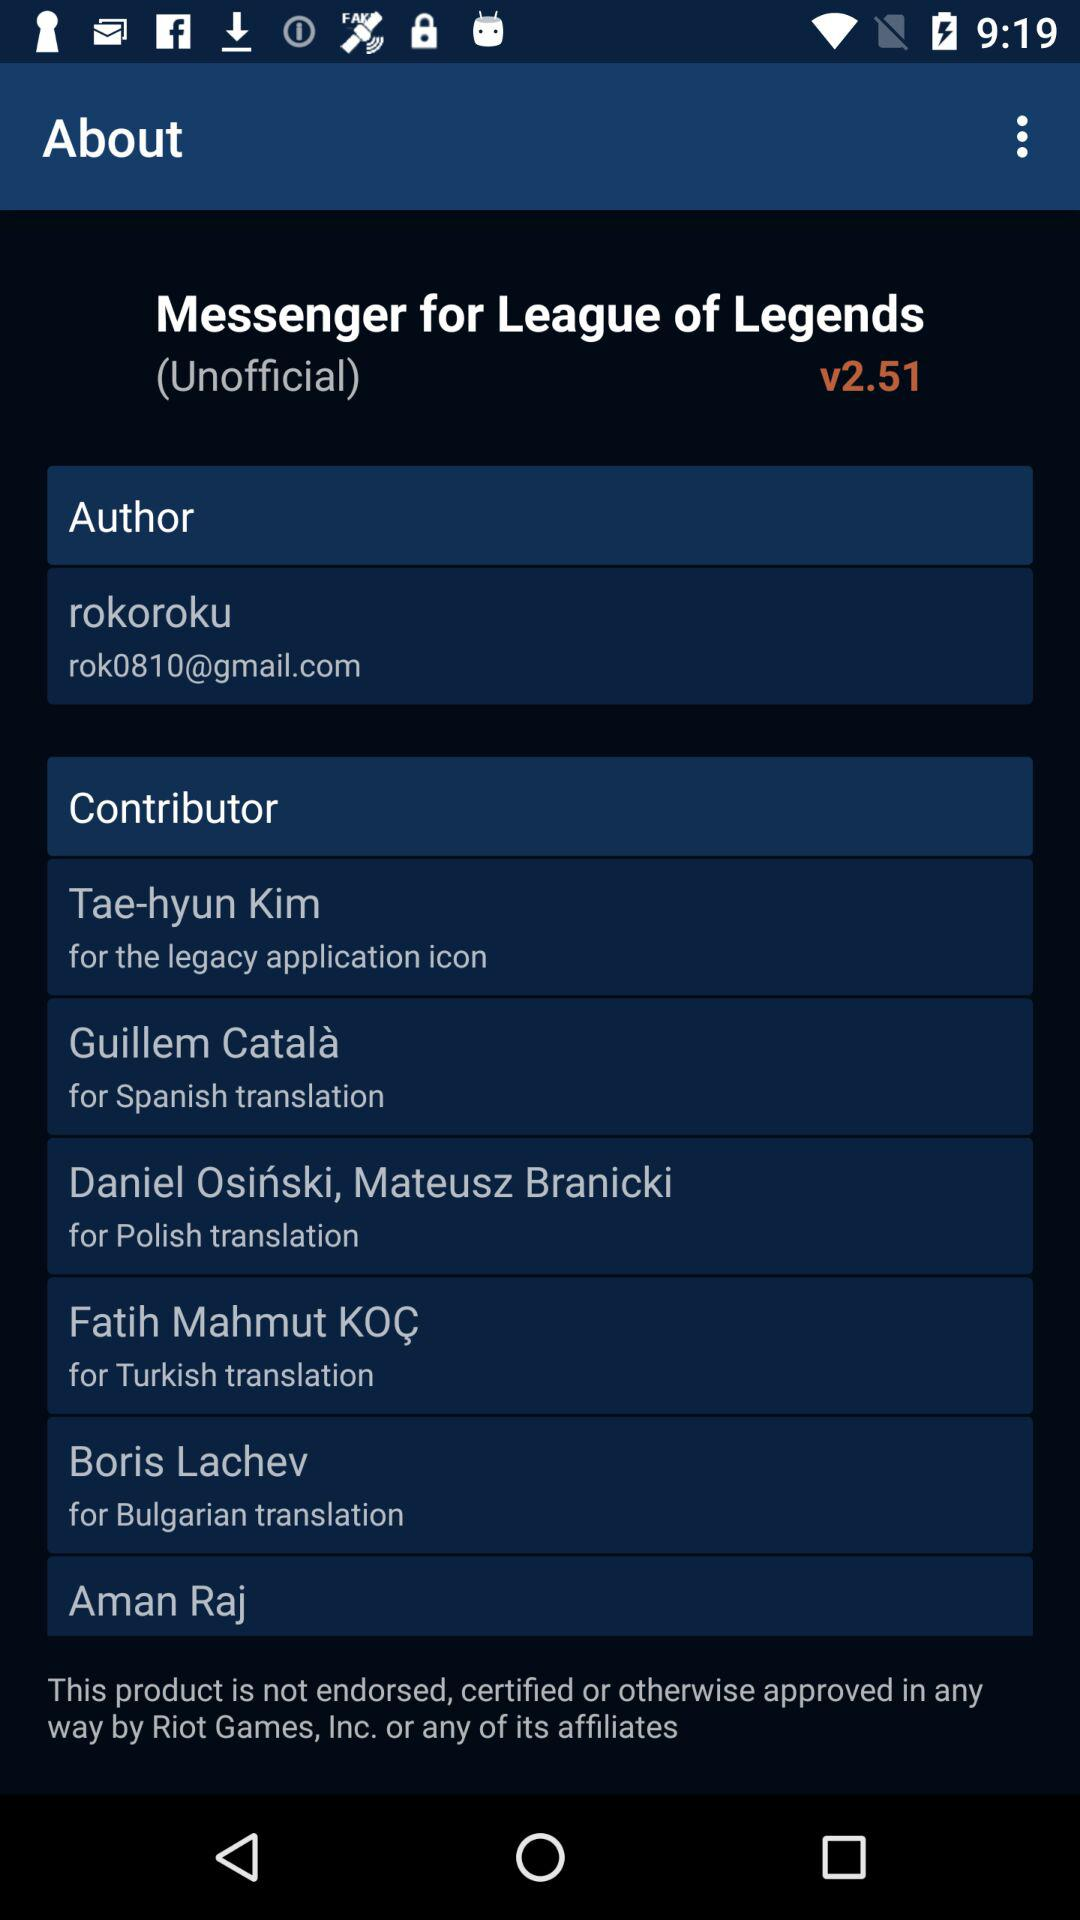How many contributors have provided translations for the app?
Answer the question using a single word or phrase. 6 